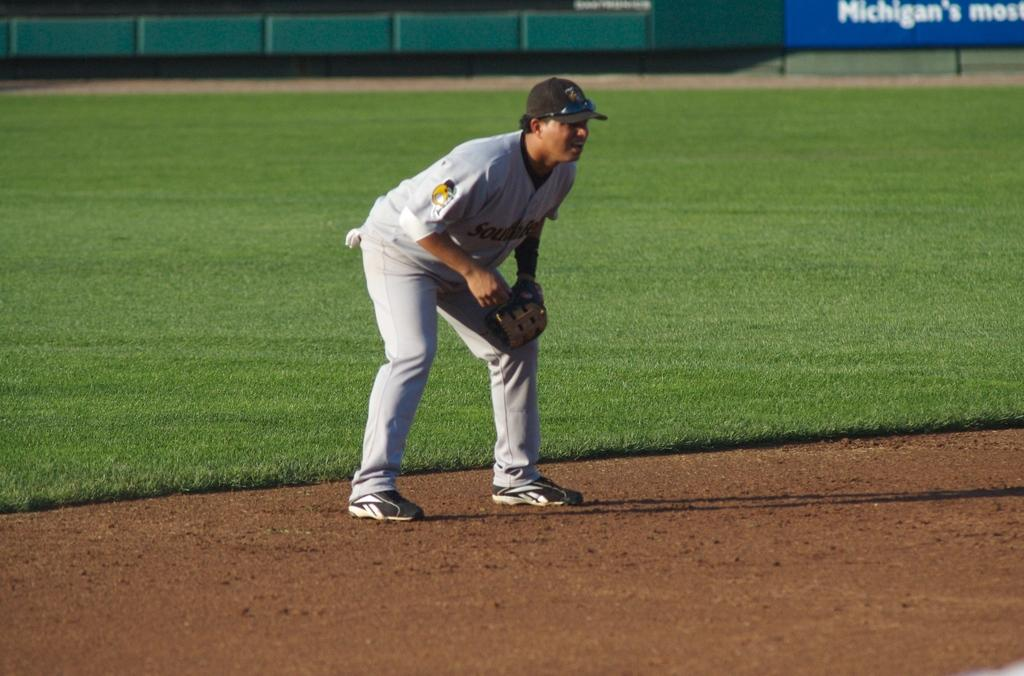Provide a one-sentence caption for the provided image. A blue sign with Michigan written on it is shown on the outfield wall of a baseball field while a fielder readies for the next play. 